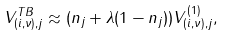<formula> <loc_0><loc_0><loc_500><loc_500>V _ { ( i , \nu ) , j } ^ { T B } \approx ( n _ { j } + \lambda ( 1 - n _ { j } ) ) V _ { ( i , \nu ) , j } ^ { ( 1 ) } ,</formula> 